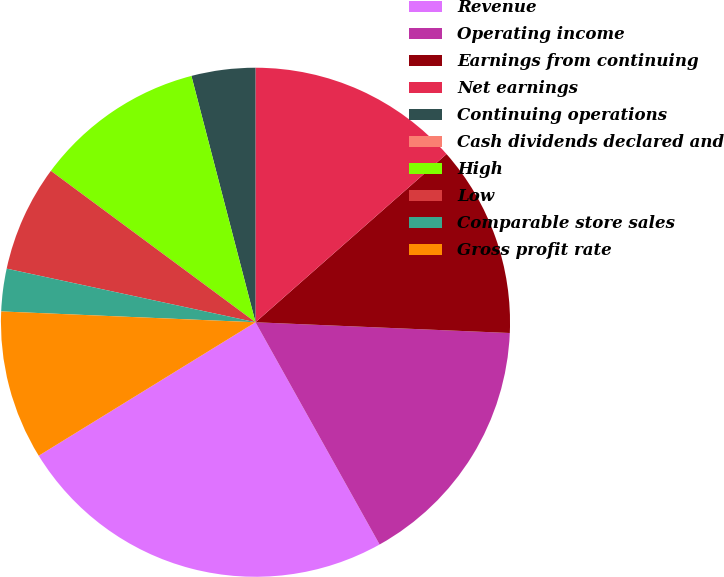<chart> <loc_0><loc_0><loc_500><loc_500><pie_chart><fcel>Revenue<fcel>Operating income<fcel>Earnings from continuing<fcel>Net earnings<fcel>Continuing operations<fcel>Cash dividends declared and<fcel>High<fcel>Low<fcel>Comparable store sales<fcel>Gross profit rate<nl><fcel>24.32%<fcel>16.22%<fcel>12.16%<fcel>13.51%<fcel>4.05%<fcel>0.0%<fcel>10.81%<fcel>6.76%<fcel>2.7%<fcel>9.46%<nl></chart> 